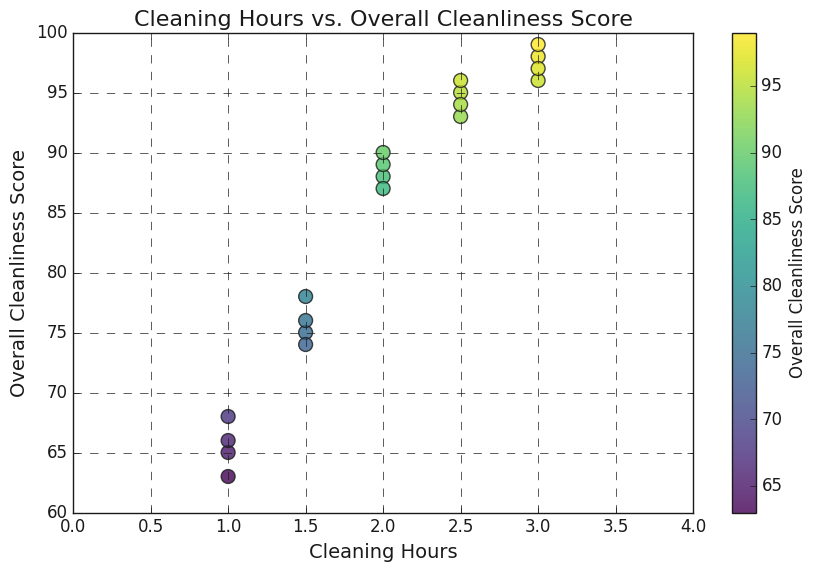Which Cleaning Hours value has the highest Overall Cleanliness Score? Look for the data point with the highest y-coordinate (Overall Cleanliness Score) and trace horizontally to find the corresponding x-coordinate (Cleaning Hours). The highest Overall Cleanliness Score of 99 occurs at 3 Cleaning Hours.
Answer: 3 What is the average Overall Cleanliness Score for the Cleaning Hours values of 1 and 1.5? Identify the Overall Cleanliness Scores for Cleaning Hours of 1 and 1.5. The scores for 1 are 65, 63, 68, 66, and for 1.5 they are 75, 74, 76, 78. Calculate the average: (65 + 63 + 68 + 66 + 75 + 74 + 76 + 78) / 8 = 73.12.
Answer: 73.12 Which point has a Cleaning Hours value more than 2 but less than 3, and what is its Overall Cleanliness Score? Check the scatter plot for points where the x-coordinate is between 2 and 3. The points at (2.5, 95), (2.5, 93), (2.5, 96), and (2.5, 94) satisfy this range. The values of Overall Cleanliness Score are 95, 93, 96, 94.
Answer: 95, 93, 96, 94 What is the Overall Cleanliness Score for the minimum Cleaning Hours value? Identify the minimum value of Cleaning Hours, which is 1. Trace vertically from the x-coordinate of 1 to find the corresponding y-values of Overall Cleanliness Score, which are 65, 63, 68, 66.
Answer: 65, 63, 68, 66 What is the color representation for the highest Overall Cleanliness Score? The highest Overall Cleanliness Score is 99. Notice the color of the scatter point representing 99; it's located using the color gradient (viridis). The point is in the greenish range of the colormap.
Answer: Greenish Which Cleaning Hours value has more than one point with the same Overall Cleanliness Score? Look for overlapping points. The value 3 has multiple points: (3, 98), (3, 96), (3, 99), (3, 97); note that while these are not identical points, they help identify closely positioned values. There is no exact overlap in the dataset provided.
Answer: None 